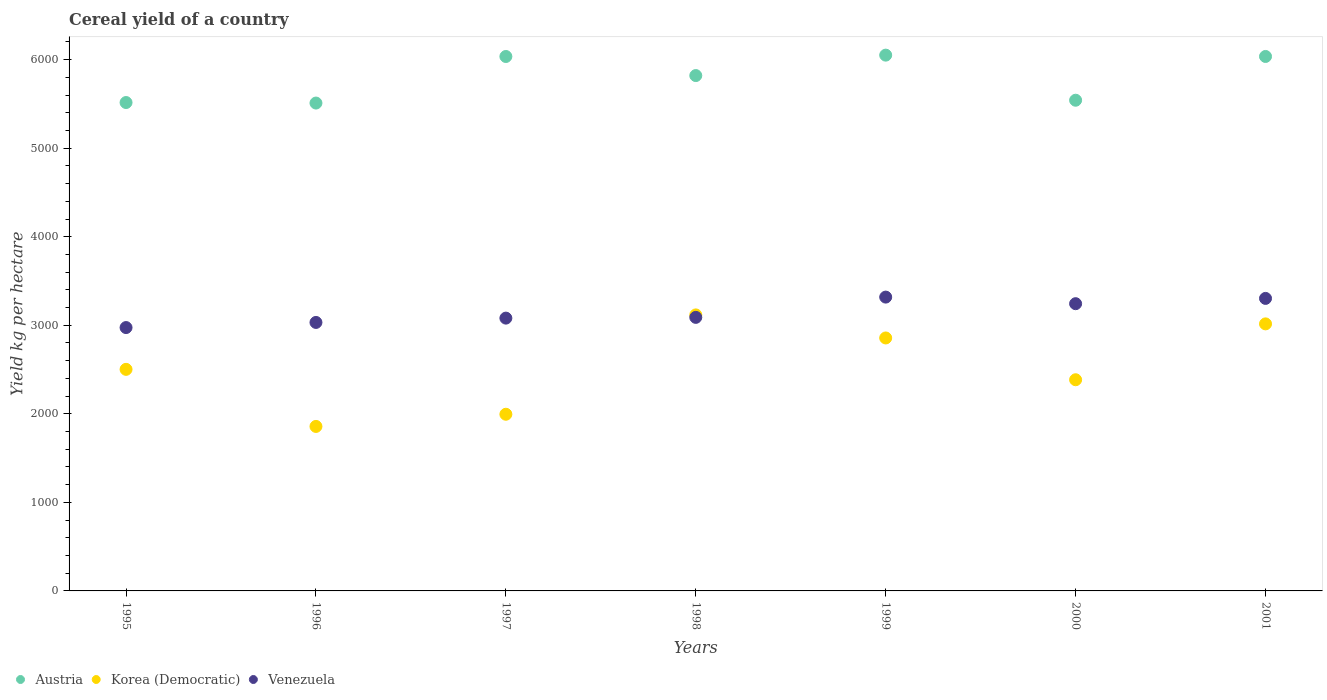How many different coloured dotlines are there?
Your response must be concise. 3. What is the total cereal yield in Venezuela in 1998?
Make the answer very short. 3089.12. Across all years, what is the maximum total cereal yield in Austria?
Your answer should be compact. 6050.5. Across all years, what is the minimum total cereal yield in Austria?
Your answer should be very brief. 5509.36. In which year was the total cereal yield in Korea (Democratic) minimum?
Provide a short and direct response. 1996. What is the total total cereal yield in Austria in the graph?
Provide a short and direct response. 4.05e+04. What is the difference between the total cereal yield in Korea (Democratic) in 1998 and that in 1999?
Your response must be concise. 260.31. What is the difference between the total cereal yield in Korea (Democratic) in 1995 and the total cereal yield in Venezuela in 1996?
Your answer should be compact. -529.81. What is the average total cereal yield in Venezuela per year?
Keep it short and to the point. 3148.7. In the year 2000, what is the difference between the total cereal yield in Venezuela and total cereal yield in Austria?
Your answer should be compact. -2297.66. What is the ratio of the total cereal yield in Austria in 1997 to that in 2001?
Provide a succinct answer. 1. Is the total cereal yield in Austria in 1998 less than that in 2000?
Your answer should be very brief. No. What is the difference between the highest and the second highest total cereal yield in Austria?
Provide a short and direct response. 14.98. What is the difference between the highest and the lowest total cereal yield in Austria?
Your response must be concise. 541.15. In how many years, is the total cereal yield in Venezuela greater than the average total cereal yield in Venezuela taken over all years?
Give a very brief answer. 3. Is the total cereal yield in Austria strictly greater than the total cereal yield in Korea (Democratic) over the years?
Your response must be concise. Yes. Is the total cereal yield in Korea (Democratic) strictly less than the total cereal yield in Austria over the years?
Your answer should be very brief. Yes. How many years are there in the graph?
Your answer should be very brief. 7. Are the values on the major ticks of Y-axis written in scientific E-notation?
Give a very brief answer. No. Does the graph contain any zero values?
Your answer should be very brief. No. Where does the legend appear in the graph?
Make the answer very short. Bottom left. How many legend labels are there?
Your answer should be compact. 3. What is the title of the graph?
Provide a succinct answer. Cereal yield of a country. What is the label or title of the Y-axis?
Your answer should be very brief. Yield kg per hectare. What is the Yield kg per hectare of Austria in 1995?
Your answer should be very brief. 5515.28. What is the Yield kg per hectare in Korea (Democratic) in 1995?
Provide a short and direct response. 2502.13. What is the Yield kg per hectare of Venezuela in 1995?
Provide a short and direct response. 2974.07. What is the Yield kg per hectare in Austria in 1996?
Make the answer very short. 5509.36. What is the Yield kg per hectare of Korea (Democratic) in 1996?
Give a very brief answer. 1857.58. What is the Yield kg per hectare of Venezuela in 1996?
Provide a succinct answer. 3031.94. What is the Yield kg per hectare in Austria in 1997?
Provide a succinct answer. 6035.25. What is the Yield kg per hectare of Korea (Democratic) in 1997?
Your answer should be very brief. 1995.1. What is the Yield kg per hectare of Venezuela in 1997?
Provide a short and direct response. 3080.72. What is the Yield kg per hectare of Austria in 1998?
Your response must be concise. 5819.79. What is the Yield kg per hectare of Korea (Democratic) in 1998?
Offer a very short reply. 3116.97. What is the Yield kg per hectare of Venezuela in 1998?
Offer a very short reply. 3089.12. What is the Yield kg per hectare in Austria in 1999?
Your answer should be very brief. 6050.5. What is the Yield kg per hectare in Korea (Democratic) in 1999?
Offer a very short reply. 2856.66. What is the Yield kg per hectare in Venezuela in 1999?
Your answer should be compact. 3318.07. What is the Yield kg per hectare of Austria in 2000?
Your response must be concise. 5541.31. What is the Yield kg per hectare in Korea (Democratic) in 2000?
Your answer should be compact. 2384.74. What is the Yield kg per hectare of Venezuela in 2000?
Provide a succinct answer. 3243.65. What is the Yield kg per hectare in Austria in 2001?
Provide a succinct answer. 6035.52. What is the Yield kg per hectare in Korea (Democratic) in 2001?
Offer a terse response. 3015.7. What is the Yield kg per hectare in Venezuela in 2001?
Make the answer very short. 3303.35. Across all years, what is the maximum Yield kg per hectare in Austria?
Your answer should be compact. 6050.5. Across all years, what is the maximum Yield kg per hectare in Korea (Democratic)?
Your response must be concise. 3116.97. Across all years, what is the maximum Yield kg per hectare in Venezuela?
Keep it short and to the point. 3318.07. Across all years, what is the minimum Yield kg per hectare in Austria?
Keep it short and to the point. 5509.36. Across all years, what is the minimum Yield kg per hectare of Korea (Democratic)?
Give a very brief answer. 1857.58. Across all years, what is the minimum Yield kg per hectare in Venezuela?
Offer a very short reply. 2974.07. What is the total Yield kg per hectare of Austria in the graph?
Your response must be concise. 4.05e+04. What is the total Yield kg per hectare of Korea (Democratic) in the graph?
Give a very brief answer. 1.77e+04. What is the total Yield kg per hectare of Venezuela in the graph?
Provide a short and direct response. 2.20e+04. What is the difference between the Yield kg per hectare of Austria in 1995 and that in 1996?
Ensure brevity in your answer.  5.93. What is the difference between the Yield kg per hectare in Korea (Democratic) in 1995 and that in 1996?
Ensure brevity in your answer.  644.55. What is the difference between the Yield kg per hectare of Venezuela in 1995 and that in 1996?
Make the answer very short. -57.87. What is the difference between the Yield kg per hectare of Austria in 1995 and that in 1997?
Your answer should be compact. -519.97. What is the difference between the Yield kg per hectare in Korea (Democratic) in 1995 and that in 1997?
Your answer should be compact. 507.03. What is the difference between the Yield kg per hectare in Venezuela in 1995 and that in 1997?
Provide a short and direct response. -106.66. What is the difference between the Yield kg per hectare of Austria in 1995 and that in 1998?
Offer a very short reply. -304.51. What is the difference between the Yield kg per hectare in Korea (Democratic) in 1995 and that in 1998?
Provide a succinct answer. -614.84. What is the difference between the Yield kg per hectare of Venezuela in 1995 and that in 1998?
Offer a very short reply. -115.06. What is the difference between the Yield kg per hectare in Austria in 1995 and that in 1999?
Your response must be concise. -535.22. What is the difference between the Yield kg per hectare in Korea (Democratic) in 1995 and that in 1999?
Make the answer very short. -354.54. What is the difference between the Yield kg per hectare in Venezuela in 1995 and that in 1999?
Give a very brief answer. -344. What is the difference between the Yield kg per hectare in Austria in 1995 and that in 2000?
Your response must be concise. -26.02. What is the difference between the Yield kg per hectare in Korea (Democratic) in 1995 and that in 2000?
Your answer should be compact. 117.39. What is the difference between the Yield kg per hectare in Venezuela in 1995 and that in 2000?
Give a very brief answer. -269.59. What is the difference between the Yield kg per hectare of Austria in 1995 and that in 2001?
Offer a terse response. -520.24. What is the difference between the Yield kg per hectare in Korea (Democratic) in 1995 and that in 2001?
Offer a very short reply. -513.58. What is the difference between the Yield kg per hectare of Venezuela in 1995 and that in 2001?
Your response must be concise. -329.29. What is the difference between the Yield kg per hectare of Austria in 1996 and that in 1997?
Ensure brevity in your answer.  -525.89. What is the difference between the Yield kg per hectare of Korea (Democratic) in 1996 and that in 1997?
Offer a terse response. -137.52. What is the difference between the Yield kg per hectare in Venezuela in 1996 and that in 1997?
Your response must be concise. -48.78. What is the difference between the Yield kg per hectare of Austria in 1996 and that in 1998?
Keep it short and to the point. -310.44. What is the difference between the Yield kg per hectare in Korea (Democratic) in 1996 and that in 1998?
Provide a succinct answer. -1259.39. What is the difference between the Yield kg per hectare in Venezuela in 1996 and that in 1998?
Offer a terse response. -57.18. What is the difference between the Yield kg per hectare in Austria in 1996 and that in 1999?
Make the answer very short. -541.15. What is the difference between the Yield kg per hectare in Korea (Democratic) in 1996 and that in 1999?
Your answer should be very brief. -999.08. What is the difference between the Yield kg per hectare of Venezuela in 1996 and that in 1999?
Give a very brief answer. -286.13. What is the difference between the Yield kg per hectare of Austria in 1996 and that in 2000?
Provide a succinct answer. -31.95. What is the difference between the Yield kg per hectare of Korea (Democratic) in 1996 and that in 2000?
Give a very brief answer. -527.16. What is the difference between the Yield kg per hectare in Venezuela in 1996 and that in 2000?
Keep it short and to the point. -211.71. What is the difference between the Yield kg per hectare in Austria in 1996 and that in 2001?
Your response must be concise. -526.16. What is the difference between the Yield kg per hectare in Korea (Democratic) in 1996 and that in 2001?
Provide a short and direct response. -1158.12. What is the difference between the Yield kg per hectare in Venezuela in 1996 and that in 2001?
Keep it short and to the point. -271.42. What is the difference between the Yield kg per hectare in Austria in 1997 and that in 1998?
Make the answer very short. 215.46. What is the difference between the Yield kg per hectare of Korea (Democratic) in 1997 and that in 1998?
Your answer should be very brief. -1121.87. What is the difference between the Yield kg per hectare in Austria in 1997 and that in 1999?
Your answer should be compact. -15.25. What is the difference between the Yield kg per hectare of Korea (Democratic) in 1997 and that in 1999?
Your answer should be compact. -861.57. What is the difference between the Yield kg per hectare of Venezuela in 1997 and that in 1999?
Ensure brevity in your answer.  -237.35. What is the difference between the Yield kg per hectare in Austria in 1997 and that in 2000?
Ensure brevity in your answer.  493.94. What is the difference between the Yield kg per hectare in Korea (Democratic) in 1997 and that in 2000?
Provide a short and direct response. -389.64. What is the difference between the Yield kg per hectare of Venezuela in 1997 and that in 2000?
Offer a terse response. -162.93. What is the difference between the Yield kg per hectare of Austria in 1997 and that in 2001?
Provide a short and direct response. -0.27. What is the difference between the Yield kg per hectare of Korea (Democratic) in 1997 and that in 2001?
Make the answer very short. -1020.61. What is the difference between the Yield kg per hectare in Venezuela in 1997 and that in 2001?
Offer a terse response. -222.63. What is the difference between the Yield kg per hectare in Austria in 1998 and that in 1999?
Offer a terse response. -230.71. What is the difference between the Yield kg per hectare of Korea (Democratic) in 1998 and that in 1999?
Offer a terse response. 260.31. What is the difference between the Yield kg per hectare of Venezuela in 1998 and that in 1999?
Offer a terse response. -228.95. What is the difference between the Yield kg per hectare of Austria in 1998 and that in 2000?
Provide a succinct answer. 278.49. What is the difference between the Yield kg per hectare in Korea (Democratic) in 1998 and that in 2000?
Provide a succinct answer. 732.23. What is the difference between the Yield kg per hectare of Venezuela in 1998 and that in 2000?
Your answer should be very brief. -154.53. What is the difference between the Yield kg per hectare in Austria in 1998 and that in 2001?
Keep it short and to the point. -215.73. What is the difference between the Yield kg per hectare in Korea (Democratic) in 1998 and that in 2001?
Provide a succinct answer. 101.27. What is the difference between the Yield kg per hectare in Venezuela in 1998 and that in 2001?
Your response must be concise. -214.23. What is the difference between the Yield kg per hectare of Austria in 1999 and that in 2000?
Offer a terse response. 509.19. What is the difference between the Yield kg per hectare of Korea (Democratic) in 1999 and that in 2000?
Provide a succinct answer. 471.92. What is the difference between the Yield kg per hectare in Venezuela in 1999 and that in 2000?
Ensure brevity in your answer.  74.41. What is the difference between the Yield kg per hectare in Austria in 1999 and that in 2001?
Your answer should be very brief. 14.98. What is the difference between the Yield kg per hectare in Korea (Democratic) in 1999 and that in 2001?
Make the answer very short. -159.04. What is the difference between the Yield kg per hectare in Venezuela in 1999 and that in 2001?
Ensure brevity in your answer.  14.71. What is the difference between the Yield kg per hectare of Austria in 2000 and that in 2001?
Provide a succinct answer. -494.21. What is the difference between the Yield kg per hectare of Korea (Democratic) in 2000 and that in 2001?
Your response must be concise. -630.96. What is the difference between the Yield kg per hectare of Venezuela in 2000 and that in 2001?
Provide a short and direct response. -59.7. What is the difference between the Yield kg per hectare of Austria in 1995 and the Yield kg per hectare of Korea (Democratic) in 1996?
Give a very brief answer. 3657.7. What is the difference between the Yield kg per hectare of Austria in 1995 and the Yield kg per hectare of Venezuela in 1996?
Provide a succinct answer. 2483.35. What is the difference between the Yield kg per hectare of Korea (Democratic) in 1995 and the Yield kg per hectare of Venezuela in 1996?
Ensure brevity in your answer.  -529.81. What is the difference between the Yield kg per hectare of Austria in 1995 and the Yield kg per hectare of Korea (Democratic) in 1997?
Offer a terse response. 3520.19. What is the difference between the Yield kg per hectare of Austria in 1995 and the Yield kg per hectare of Venezuela in 1997?
Your answer should be very brief. 2434.57. What is the difference between the Yield kg per hectare in Korea (Democratic) in 1995 and the Yield kg per hectare in Venezuela in 1997?
Give a very brief answer. -578.59. What is the difference between the Yield kg per hectare of Austria in 1995 and the Yield kg per hectare of Korea (Democratic) in 1998?
Provide a succinct answer. 2398.31. What is the difference between the Yield kg per hectare of Austria in 1995 and the Yield kg per hectare of Venezuela in 1998?
Provide a short and direct response. 2426.16. What is the difference between the Yield kg per hectare of Korea (Democratic) in 1995 and the Yield kg per hectare of Venezuela in 1998?
Offer a very short reply. -586.99. What is the difference between the Yield kg per hectare in Austria in 1995 and the Yield kg per hectare in Korea (Democratic) in 1999?
Make the answer very short. 2658.62. What is the difference between the Yield kg per hectare of Austria in 1995 and the Yield kg per hectare of Venezuela in 1999?
Ensure brevity in your answer.  2197.22. What is the difference between the Yield kg per hectare in Korea (Democratic) in 1995 and the Yield kg per hectare in Venezuela in 1999?
Your response must be concise. -815.94. What is the difference between the Yield kg per hectare in Austria in 1995 and the Yield kg per hectare in Korea (Democratic) in 2000?
Provide a short and direct response. 3130.54. What is the difference between the Yield kg per hectare of Austria in 1995 and the Yield kg per hectare of Venezuela in 2000?
Keep it short and to the point. 2271.63. What is the difference between the Yield kg per hectare in Korea (Democratic) in 1995 and the Yield kg per hectare in Venezuela in 2000?
Offer a terse response. -741.52. What is the difference between the Yield kg per hectare in Austria in 1995 and the Yield kg per hectare in Korea (Democratic) in 2001?
Provide a short and direct response. 2499.58. What is the difference between the Yield kg per hectare in Austria in 1995 and the Yield kg per hectare in Venezuela in 2001?
Give a very brief answer. 2211.93. What is the difference between the Yield kg per hectare in Korea (Democratic) in 1995 and the Yield kg per hectare in Venezuela in 2001?
Keep it short and to the point. -801.23. What is the difference between the Yield kg per hectare of Austria in 1996 and the Yield kg per hectare of Korea (Democratic) in 1997?
Offer a very short reply. 3514.26. What is the difference between the Yield kg per hectare of Austria in 1996 and the Yield kg per hectare of Venezuela in 1997?
Your answer should be very brief. 2428.64. What is the difference between the Yield kg per hectare of Korea (Democratic) in 1996 and the Yield kg per hectare of Venezuela in 1997?
Give a very brief answer. -1223.14. What is the difference between the Yield kg per hectare in Austria in 1996 and the Yield kg per hectare in Korea (Democratic) in 1998?
Your answer should be compact. 2392.39. What is the difference between the Yield kg per hectare in Austria in 1996 and the Yield kg per hectare in Venezuela in 1998?
Provide a short and direct response. 2420.24. What is the difference between the Yield kg per hectare of Korea (Democratic) in 1996 and the Yield kg per hectare of Venezuela in 1998?
Make the answer very short. -1231.54. What is the difference between the Yield kg per hectare in Austria in 1996 and the Yield kg per hectare in Korea (Democratic) in 1999?
Provide a succinct answer. 2652.69. What is the difference between the Yield kg per hectare in Austria in 1996 and the Yield kg per hectare in Venezuela in 1999?
Give a very brief answer. 2191.29. What is the difference between the Yield kg per hectare in Korea (Democratic) in 1996 and the Yield kg per hectare in Venezuela in 1999?
Make the answer very short. -1460.48. What is the difference between the Yield kg per hectare in Austria in 1996 and the Yield kg per hectare in Korea (Democratic) in 2000?
Your response must be concise. 3124.61. What is the difference between the Yield kg per hectare in Austria in 1996 and the Yield kg per hectare in Venezuela in 2000?
Ensure brevity in your answer.  2265.7. What is the difference between the Yield kg per hectare in Korea (Democratic) in 1996 and the Yield kg per hectare in Venezuela in 2000?
Give a very brief answer. -1386.07. What is the difference between the Yield kg per hectare of Austria in 1996 and the Yield kg per hectare of Korea (Democratic) in 2001?
Give a very brief answer. 2493.65. What is the difference between the Yield kg per hectare of Austria in 1996 and the Yield kg per hectare of Venezuela in 2001?
Your response must be concise. 2206. What is the difference between the Yield kg per hectare in Korea (Democratic) in 1996 and the Yield kg per hectare in Venezuela in 2001?
Keep it short and to the point. -1445.77. What is the difference between the Yield kg per hectare in Austria in 1997 and the Yield kg per hectare in Korea (Democratic) in 1998?
Make the answer very short. 2918.28. What is the difference between the Yield kg per hectare in Austria in 1997 and the Yield kg per hectare in Venezuela in 1998?
Offer a terse response. 2946.13. What is the difference between the Yield kg per hectare of Korea (Democratic) in 1997 and the Yield kg per hectare of Venezuela in 1998?
Your answer should be compact. -1094.02. What is the difference between the Yield kg per hectare of Austria in 1997 and the Yield kg per hectare of Korea (Democratic) in 1999?
Offer a very short reply. 3178.59. What is the difference between the Yield kg per hectare in Austria in 1997 and the Yield kg per hectare in Venezuela in 1999?
Your response must be concise. 2717.18. What is the difference between the Yield kg per hectare in Korea (Democratic) in 1997 and the Yield kg per hectare in Venezuela in 1999?
Your answer should be very brief. -1322.97. What is the difference between the Yield kg per hectare in Austria in 1997 and the Yield kg per hectare in Korea (Democratic) in 2000?
Offer a terse response. 3650.51. What is the difference between the Yield kg per hectare of Austria in 1997 and the Yield kg per hectare of Venezuela in 2000?
Provide a succinct answer. 2791.6. What is the difference between the Yield kg per hectare in Korea (Democratic) in 1997 and the Yield kg per hectare in Venezuela in 2000?
Make the answer very short. -1248.55. What is the difference between the Yield kg per hectare of Austria in 1997 and the Yield kg per hectare of Korea (Democratic) in 2001?
Offer a very short reply. 3019.55. What is the difference between the Yield kg per hectare in Austria in 1997 and the Yield kg per hectare in Venezuela in 2001?
Ensure brevity in your answer.  2731.9. What is the difference between the Yield kg per hectare of Korea (Democratic) in 1997 and the Yield kg per hectare of Venezuela in 2001?
Provide a short and direct response. -1308.26. What is the difference between the Yield kg per hectare of Austria in 1998 and the Yield kg per hectare of Korea (Democratic) in 1999?
Offer a very short reply. 2963.13. What is the difference between the Yield kg per hectare in Austria in 1998 and the Yield kg per hectare in Venezuela in 1999?
Provide a succinct answer. 2501.73. What is the difference between the Yield kg per hectare in Korea (Democratic) in 1998 and the Yield kg per hectare in Venezuela in 1999?
Ensure brevity in your answer.  -201.09. What is the difference between the Yield kg per hectare of Austria in 1998 and the Yield kg per hectare of Korea (Democratic) in 2000?
Offer a very short reply. 3435.05. What is the difference between the Yield kg per hectare of Austria in 1998 and the Yield kg per hectare of Venezuela in 2000?
Your answer should be compact. 2576.14. What is the difference between the Yield kg per hectare of Korea (Democratic) in 1998 and the Yield kg per hectare of Venezuela in 2000?
Keep it short and to the point. -126.68. What is the difference between the Yield kg per hectare of Austria in 1998 and the Yield kg per hectare of Korea (Democratic) in 2001?
Provide a succinct answer. 2804.09. What is the difference between the Yield kg per hectare in Austria in 1998 and the Yield kg per hectare in Venezuela in 2001?
Provide a succinct answer. 2516.44. What is the difference between the Yield kg per hectare of Korea (Democratic) in 1998 and the Yield kg per hectare of Venezuela in 2001?
Give a very brief answer. -186.38. What is the difference between the Yield kg per hectare in Austria in 1999 and the Yield kg per hectare in Korea (Democratic) in 2000?
Keep it short and to the point. 3665.76. What is the difference between the Yield kg per hectare of Austria in 1999 and the Yield kg per hectare of Venezuela in 2000?
Your response must be concise. 2806.85. What is the difference between the Yield kg per hectare in Korea (Democratic) in 1999 and the Yield kg per hectare in Venezuela in 2000?
Your response must be concise. -386.99. What is the difference between the Yield kg per hectare of Austria in 1999 and the Yield kg per hectare of Korea (Democratic) in 2001?
Give a very brief answer. 3034.8. What is the difference between the Yield kg per hectare in Austria in 1999 and the Yield kg per hectare in Venezuela in 2001?
Offer a very short reply. 2747.15. What is the difference between the Yield kg per hectare of Korea (Democratic) in 1999 and the Yield kg per hectare of Venezuela in 2001?
Offer a terse response. -446.69. What is the difference between the Yield kg per hectare of Austria in 2000 and the Yield kg per hectare of Korea (Democratic) in 2001?
Offer a very short reply. 2525.6. What is the difference between the Yield kg per hectare in Austria in 2000 and the Yield kg per hectare in Venezuela in 2001?
Provide a succinct answer. 2237.95. What is the difference between the Yield kg per hectare in Korea (Democratic) in 2000 and the Yield kg per hectare in Venezuela in 2001?
Keep it short and to the point. -918.61. What is the average Yield kg per hectare in Austria per year?
Ensure brevity in your answer.  5786.72. What is the average Yield kg per hectare of Korea (Democratic) per year?
Offer a very short reply. 2532.7. What is the average Yield kg per hectare in Venezuela per year?
Your answer should be very brief. 3148.7. In the year 1995, what is the difference between the Yield kg per hectare of Austria and Yield kg per hectare of Korea (Democratic)?
Your response must be concise. 3013.16. In the year 1995, what is the difference between the Yield kg per hectare of Austria and Yield kg per hectare of Venezuela?
Make the answer very short. 2541.22. In the year 1995, what is the difference between the Yield kg per hectare of Korea (Democratic) and Yield kg per hectare of Venezuela?
Keep it short and to the point. -471.94. In the year 1996, what is the difference between the Yield kg per hectare of Austria and Yield kg per hectare of Korea (Democratic)?
Make the answer very short. 3651.77. In the year 1996, what is the difference between the Yield kg per hectare in Austria and Yield kg per hectare in Venezuela?
Your answer should be very brief. 2477.42. In the year 1996, what is the difference between the Yield kg per hectare in Korea (Democratic) and Yield kg per hectare in Venezuela?
Your answer should be compact. -1174.36. In the year 1997, what is the difference between the Yield kg per hectare of Austria and Yield kg per hectare of Korea (Democratic)?
Provide a short and direct response. 4040.15. In the year 1997, what is the difference between the Yield kg per hectare of Austria and Yield kg per hectare of Venezuela?
Keep it short and to the point. 2954.53. In the year 1997, what is the difference between the Yield kg per hectare of Korea (Democratic) and Yield kg per hectare of Venezuela?
Ensure brevity in your answer.  -1085.62. In the year 1998, what is the difference between the Yield kg per hectare of Austria and Yield kg per hectare of Korea (Democratic)?
Make the answer very short. 2702.82. In the year 1998, what is the difference between the Yield kg per hectare in Austria and Yield kg per hectare in Venezuela?
Your answer should be very brief. 2730.67. In the year 1998, what is the difference between the Yield kg per hectare of Korea (Democratic) and Yield kg per hectare of Venezuela?
Keep it short and to the point. 27.85. In the year 1999, what is the difference between the Yield kg per hectare of Austria and Yield kg per hectare of Korea (Democratic)?
Make the answer very short. 3193.84. In the year 1999, what is the difference between the Yield kg per hectare of Austria and Yield kg per hectare of Venezuela?
Ensure brevity in your answer.  2732.44. In the year 1999, what is the difference between the Yield kg per hectare of Korea (Democratic) and Yield kg per hectare of Venezuela?
Ensure brevity in your answer.  -461.4. In the year 2000, what is the difference between the Yield kg per hectare in Austria and Yield kg per hectare in Korea (Democratic)?
Offer a very short reply. 3156.57. In the year 2000, what is the difference between the Yield kg per hectare in Austria and Yield kg per hectare in Venezuela?
Your response must be concise. 2297.66. In the year 2000, what is the difference between the Yield kg per hectare of Korea (Democratic) and Yield kg per hectare of Venezuela?
Give a very brief answer. -858.91. In the year 2001, what is the difference between the Yield kg per hectare of Austria and Yield kg per hectare of Korea (Democratic)?
Make the answer very short. 3019.82. In the year 2001, what is the difference between the Yield kg per hectare in Austria and Yield kg per hectare in Venezuela?
Your response must be concise. 2732.17. In the year 2001, what is the difference between the Yield kg per hectare of Korea (Democratic) and Yield kg per hectare of Venezuela?
Ensure brevity in your answer.  -287.65. What is the ratio of the Yield kg per hectare of Austria in 1995 to that in 1996?
Your answer should be compact. 1. What is the ratio of the Yield kg per hectare of Korea (Democratic) in 1995 to that in 1996?
Provide a succinct answer. 1.35. What is the ratio of the Yield kg per hectare of Venezuela in 1995 to that in 1996?
Your answer should be compact. 0.98. What is the ratio of the Yield kg per hectare in Austria in 1995 to that in 1997?
Offer a terse response. 0.91. What is the ratio of the Yield kg per hectare of Korea (Democratic) in 1995 to that in 1997?
Keep it short and to the point. 1.25. What is the ratio of the Yield kg per hectare in Venezuela in 1995 to that in 1997?
Provide a succinct answer. 0.97. What is the ratio of the Yield kg per hectare of Austria in 1995 to that in 1998?
Keep it short and to the point. 0.95. What is the ratio of the Yield kg per hectare of Korea (Democratic) in 1995 to that in 1998?
Provide a succinct answer. 0.8. What is the ratio of the Yield kg per hectare of Venezuela in 1995 to that in 1998?
Your answer should be compact. 0.96. What is the ratio of the Yield kg per hectare of Austria in 1995 to that in 1999?
Provide a succinct answer. 0.91. What is the ratio of the Yield kg per hectare in Korea (Democratic) in 1995 to that in 1999?
Keep it short and to the point. 0.88. What is the ratio of the Yield kg per hectare of Venezuela in 1995 to that in 1999?
Provide a succinct answer. 0.9. What is the ratio of the Yield kg per hectare of Korea (Democratic) in 1995 to that in 2000?
Offer a very short reply. 1.05. What is the ratio of the Yield kg per hectare in Venezuela in 1995 to that in 2000?
Offer a terse response. 0.92. What is the ratio of the Yield kg per hectare of Austria in 1995 to that in 2001?
Your answer should be compact. 0.91. What is the ratio of the Yield kg per hectare of Korea (Democratic) in 1995 to that in 2001?
Offer a terse response. 0.83. What is the ratio of the Yield kg per hectare in Venezuela in 1995 to that in 2001?
Give a very brief answer. 0.9. What is the ratio of the Yield kg per hectare of Austria in 1996 to that in 1997?
Offer a terse response. 0.91. What is the ratio of the Yield kg per hectare in Korea (Democratic) in 1996 to that in 1997?
Give a very brief answer. 0.93. What is the ratio of the Yield kg per hectare of Venezuela in 1996 to that in 1997?
Your response must be concise. 0.98. What is the ratio of the Yield kg per hectare of Austria in 1996 to that in 1998?
Keep it short and to the point. 0.95. What is the ratio of the Yield kg per hectare of Korea (Democratic) in 1996 to that in 1998?
Your answer should be compact. 0.6. What is the ratio of the Yield kg per hectare in Venezuela in 1996 to that in 1998?
Provide a succinct answer. 0.98. What is the ratio of the Yield kg per hectare of Austria in 1996 to that in 1999?
Your answer should be compact. 0.91. What is the ratio of the Yield kg per hectare of Korea (Democratic) in 1996 to that in 1999?
Ensure brevity in your answer.  0.65. What is the ratio of the Yield kg per hectare in Venezuela in 1996 to that in 1999?
Your response must be concise. 0.91. What is the ratio of the Yield kg per hectare of Austria in 1996 to that in 2000?
Keep it short and to the point. 0.99. What is the ratio of the Yield kg per hectare in Korea (Democratic) in 1996 to that in 2000?
Ensure brevity in your answer.  0.78. What is the ratio of the Yield kg per hectare of Venezuela in 1996 to that in 2000?
Give a very brief answer. 0.93. What is the ratio of the Yield kg per hectare in Austria in 1996 to that in 2001?
Give a very brief answer. 0.91. What is the ratio of the Yield kg per hectare of Korea (Democratic) in 1996 to that in 2001?
Your answer should be very brief. 0.62. What is the ratio of the Yield kg per hectare of Venezuela in 1996 to that in 2001?
Provide a succinct answer. 0.92. What is the ratio of the Yield kg per hectare of Austria in 1997 to that in 1998?
Ensure brevity in your answer.  1.04. What is the ratio of the Yield kg per hectare in Korea (Democratic) in 1997 to that in 1998?
Keep it short and to the point. 0.64. What is the ratio of the Yield kg per hectare of Venezuela in 1997 to that in 1998?
Provide a short and direct response. 1. What is the ratio of the Yield kg per hectare in Korea (Democratic) in 1997 to that in 1999?
Make the answer very short. 0.7. What is the ratio of the Yield kg per hectare of Venezuela in 1997 to that in 1999?
Keep it short and to the point. 0.93. What is the ratio of the Yield kg per hectare in Austria in 1997 to that in 2000?
Provide a succinct answer. 1.09. What is the ratio of the Yield kg per hectare in Korea (Democratic) in 1997 to that in 2000?
Your response must be concise. 0.84. What is the ratio of the Yield kg per hectare of Venezuela in 1997 to that in 2000?
Your response must be concise. 0.95. What is the ratio of the Yield kg per hectare in Austria in 1997 to that in 2001?
Offer a very short reply. 1. What is the ratio of the Yield kg per hectare of Korea (Democratic) in 1997 to that in 2001?
Offer a terse response. 0.66. What is the ratio of the Yield kg per hectare in Venezuela in 1997 to that in 2001?
Your answer should be compact. 0.93. What is the ratio of the Yield kg per hectare of Austria in 1998 to that in 1999?
Offer a terse response. 0.96. What is the ratio of the Yield kg per hectare of Korea (Democratic) in 1998 to that in 1999?
Make the answer very short. 1.09. What is the ratio of the Yield kg per hectare of Austria in 1998 to that in 2000?
Your answer should be very brief. 1.05. What is the ratio of the Yield kg per hectare in Korea (Democratic) in 1998 to that in 2000?
Your answer should be very brief. 1.31. What is the ratio of the Yield kg per hectare in Austria in 1998 to that in 2001?
Provide a short and direct response. 0.96. What is the ratio of the Yield kg per hectare in Korea (Democratic) in 1998 to that in 2001?
Ensure brevity in your answer.  1.03. What is the ratio of the Yield kg per hectare of Venezuela in 1998 to that in 2001?
Keep it short and to the point. 0.94. What is the ratio of the Yield kg per hectare of Austria in 1999 to that in 2000?
Make the answer very short. 1.09. What is the ratio of the Yield kg per hectare of Korea (Democratic) in 1999 to that in 2000?
Your answer should be very brief. 1.2. What is the ratio of the Yield kg per hectare of Venezuela in 1999 to that in 2000?
Make the answer very short. 1.02. What is the ratio of the Yield kg per hectare in Korea (Democratic) in 1999 to that in 2001?
Make the answer very short. 0.95. What is the ratio of the Yield kg per hectare of Austria in 2000 to that in 2001?
Provide a short and direct response. 0.92. What is the ratio of the Yield kg per hectare in Korea (Democratic) in 2000 to that in 2001?
Offer a terse response. 0.79. What is the ratio of the Yield kg per hectare in Venezuela in 2000 to that in 2001?
Your answer should be very brief. 0.98. What is the difference between the highest and the second highest Yield kg per hectare of Austria?
Your response must be concise. 14.98. What is the difference between the highest and the second highest Yield kg per hectare in Korea (Democratic)?
Give a very brief answer. 101.27. What is the difference between the highest and the second highest Yield kg per hectare in Venezuela?
Make the answer very short. 14.71. What is the difference between the highest and the lowest Yield kg per hectare in Austria?
Your answer should be very brief. 541.15. What is the difference between the highest and the lowest Yield kg per hectare in Korea (Democratic)?
Keep it short and to the point. 1259.39. What is the difference between the highest and the lowest Yield kg per hectare of Venezuela?
Keep it short and to the point. 344. 